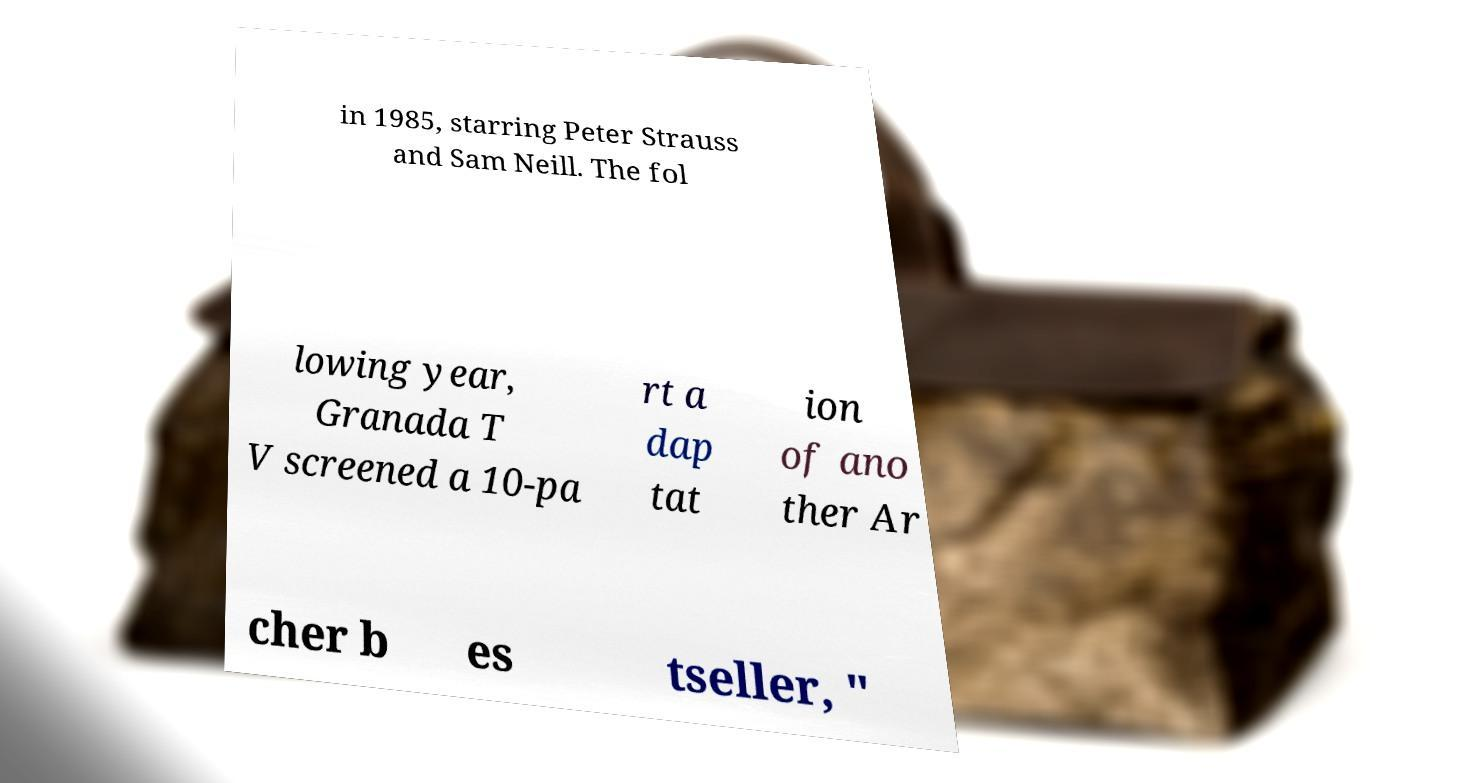Can you accurately transcribe the text from the provided image for me? in 1985, starring Peter Strauss and Sam Neill. The fol lowing year, Granada T V screened a 10-pa rt a dap tat ion of ano ther Ar cher b es tseller, " 